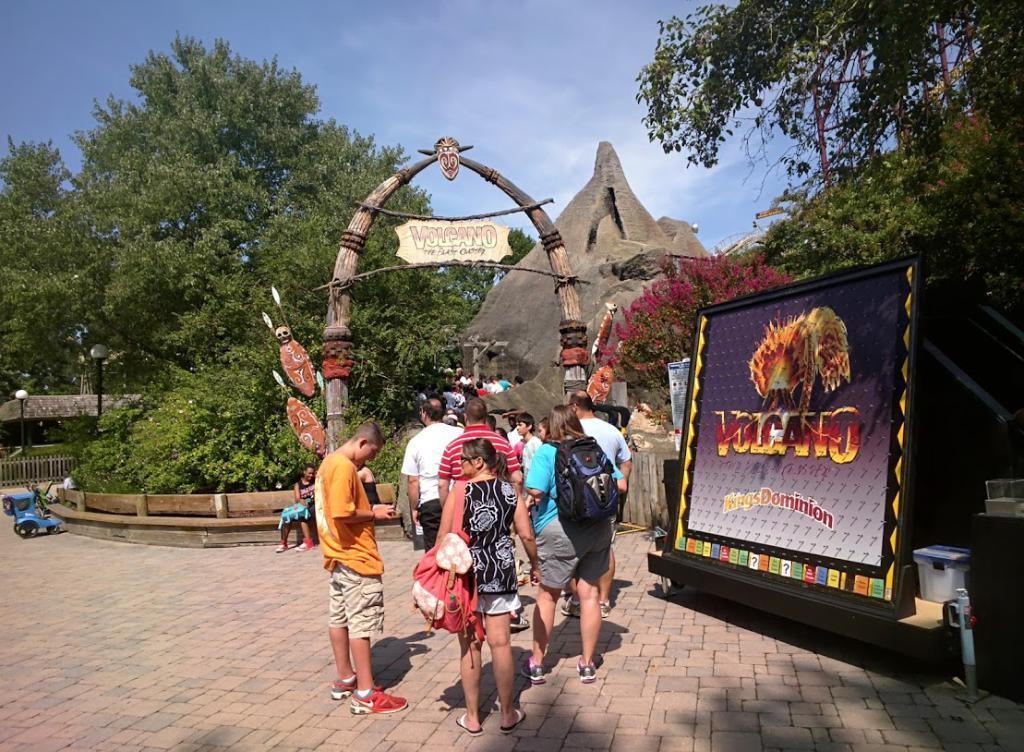Describe this image in one or two sentences. This picture describes about group of people, few are seated and few are standing, beside to them we can find a hoarding, in the background we can see few trees, poles, lights and rocks. 